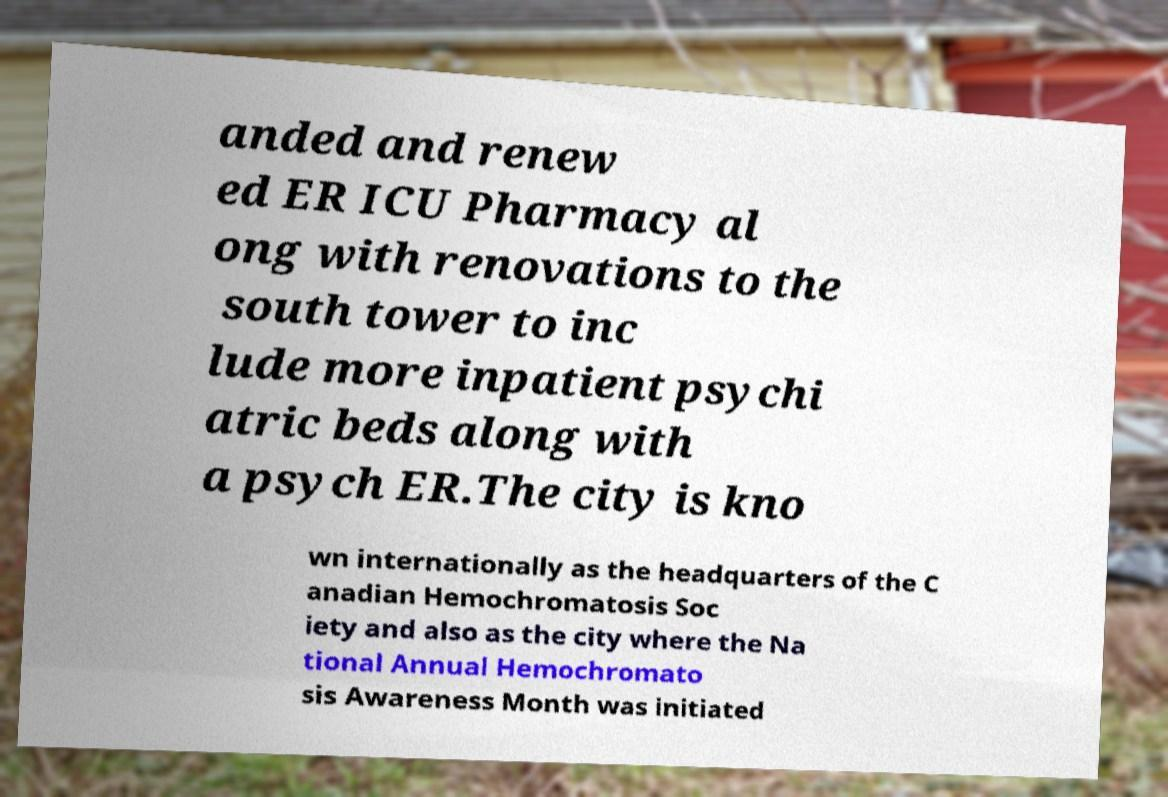Please read and relay the text visible in this image. What does it say? anded and renew ed ER ICU Pharmacy al ong with renovations to the south tower to inc lude more inpatient psychi atric beds along with a psych ER.The city is kno wn internationally as the headquarters of the C anadian Hemochromatosis Soc iety and also as the city where the Na tional Annual Hemochromato sis Awareness Month was initiated 